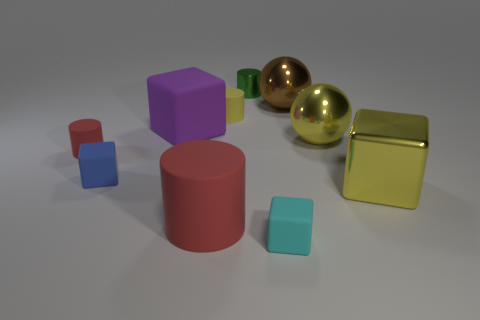Subtract all brown spheres. How many spheres are left? 1 Subtract all tiny blue matte blocks. How many blocks are left? 3 Subtract all yellow spheres. Subtract all yellow cylinders. How many spheres are left? 1 Subtract all gray cylinders. How many yellow spheres are left? 1 Subtract all small blue rubber spheres. Subtract all green cylinders. How many objects are left? 9 Add 6 large metal things. How many large metal things are left? 9 Add 1 big yellow blocks. How many big yellow blocks exist? 2 Subtract 1 purple blocks. How many objects are left? 9 Subtract all cylinders. How many objects are left? 6 Subtract 2 blocks. How many blocks are left? 2 